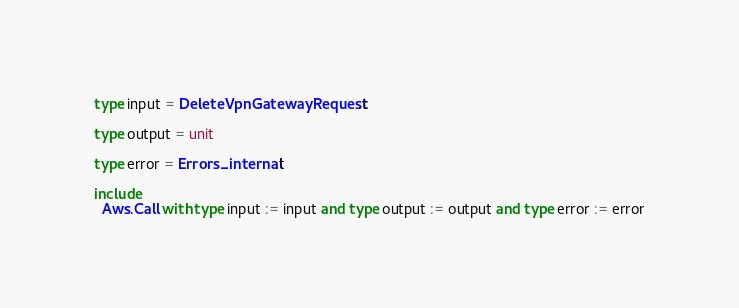Convert code to text. <code><loc_0><loc_0><loc_500><loc_500><_OCaml_>type input = DeleteVpnGatewayRequest.t

type output = unit

type error = Errors_internal.t

include
  Aws.Call with type input := input and type output := output and type error := error
</code> 